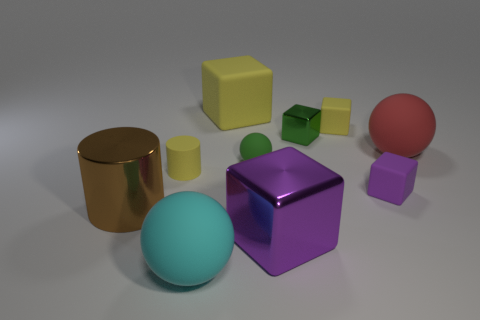Subtract all large matte spheres. How many spheres are left? 1 Subtract all cylinders. How many objects are left? 8 Subtract all red balls. How many balls are left? 2 Subtract 1 cubes. How many cubes are left? 4 Subtract all yellow cylinders. How many purple cubes are left? 2 Subtract all small yellow rubber things. Subtract all small purple rubber objects. How many objects are left? 7 Add 1 cyan things. How many cyan things are left? 2 Add 4 large red matte objects. How many large red matte objects exist? 5 Subtract 1 yellow cylinders. How many objects are left? 9 Subtract all gray cylinders. Subtract all brown balls. How many cylinders are left? 2 